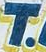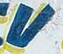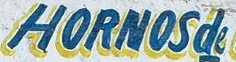What words are shown in these images in order, separated by a semicolon? T; V; HORNOSde 